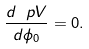Convert formula to latex. <formula><loc_0><loc_0><loc_500><loc_500>\frac { d \ p V } { d \phi _ { 0 } } = 0 .</formula> 